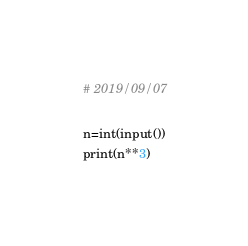Convert code to text. <code><loc_0><loc_0><loc_500><loc_500><_Python_># 2019/09/07

n=int(input())
print(n**3)</code> 